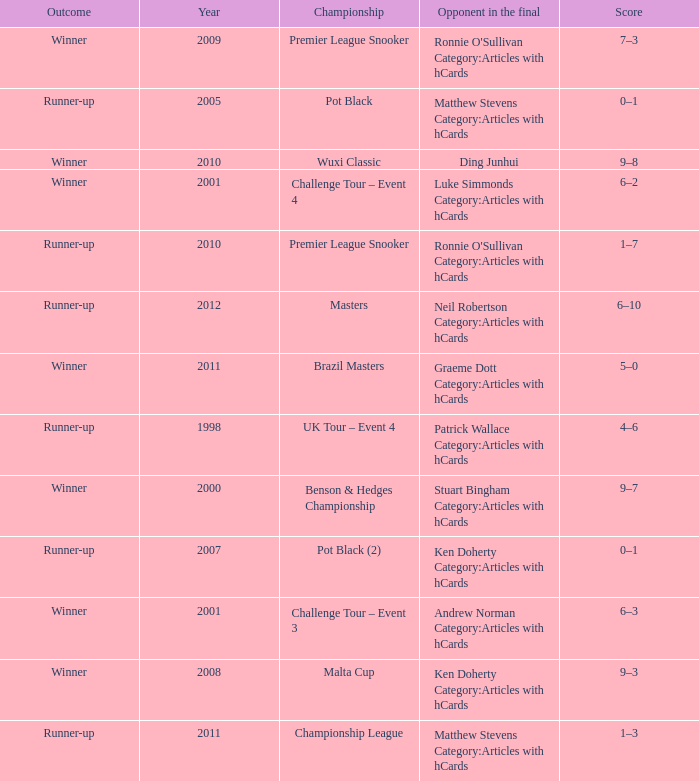What was Shaun Murphy's outcome in the Premier League Snooker championship held before 2010? Winner. 